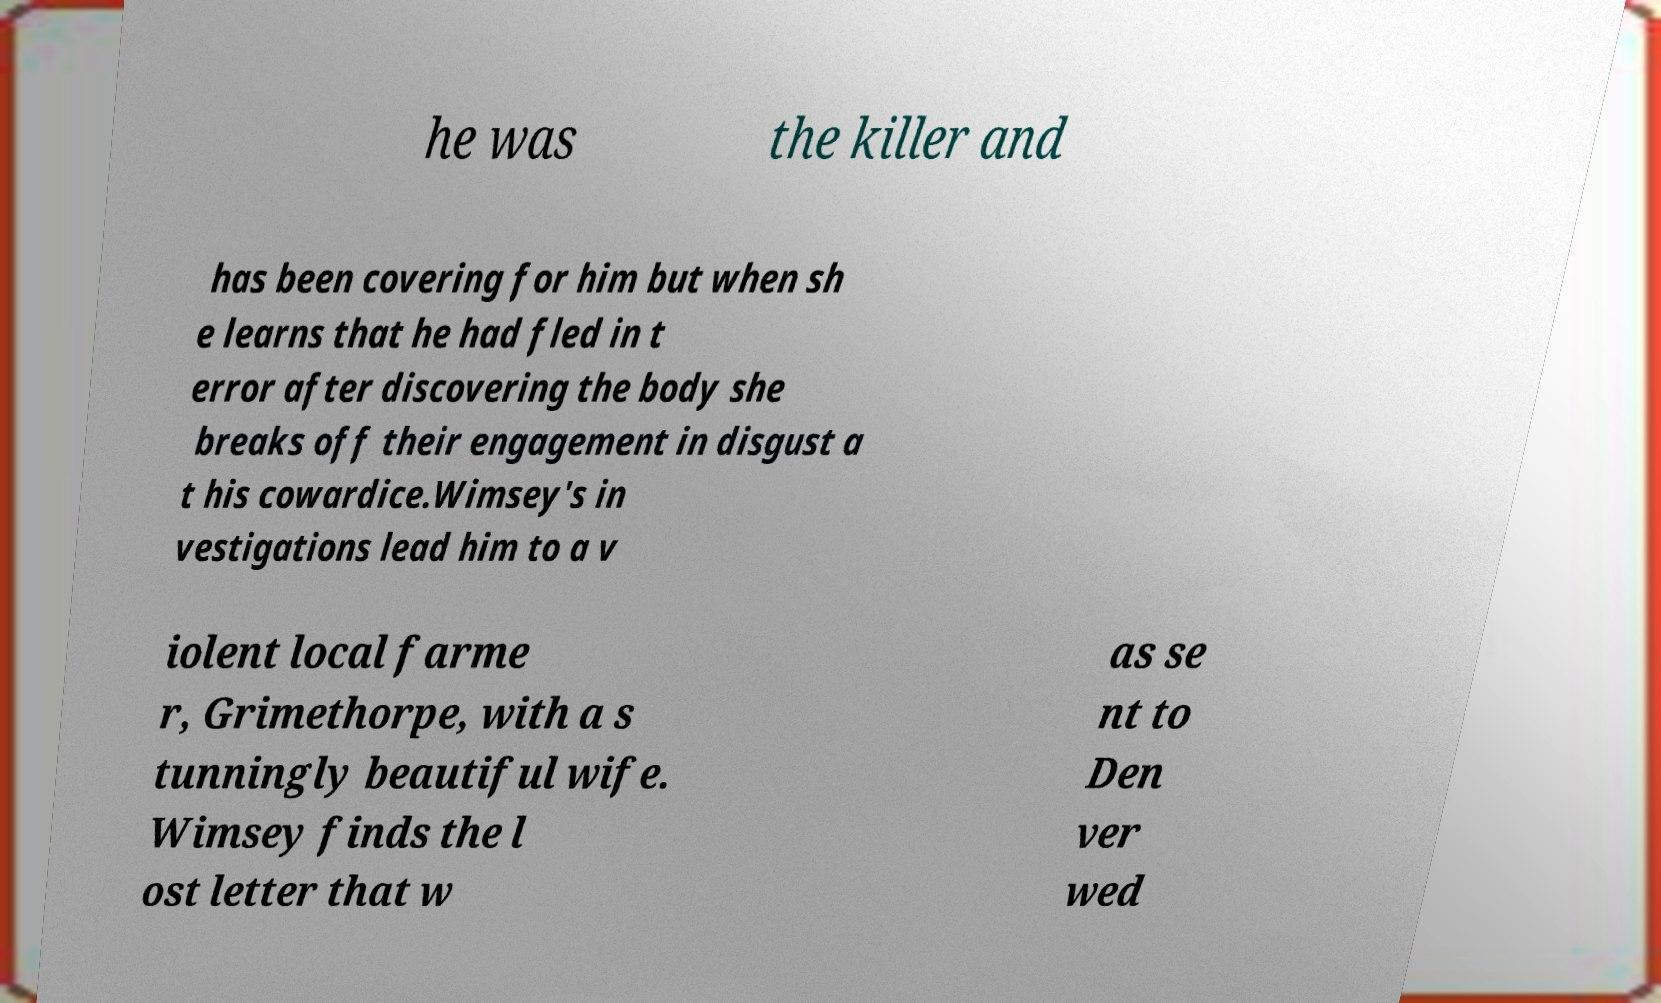Please read and relay the text visible in this image. What does it say? he was the killer and has been covering for him but when sh e learns that he had fled in t error after discovering the body she breaks off their engagement in disgust a t his cowardice.Wimsey's in vestigations lead him to a v iolent local farme r, Grimethorpe, with a s tunningly beautiful wife. Wimsey finds the l ost letter that w as se nt to Den ver wed 